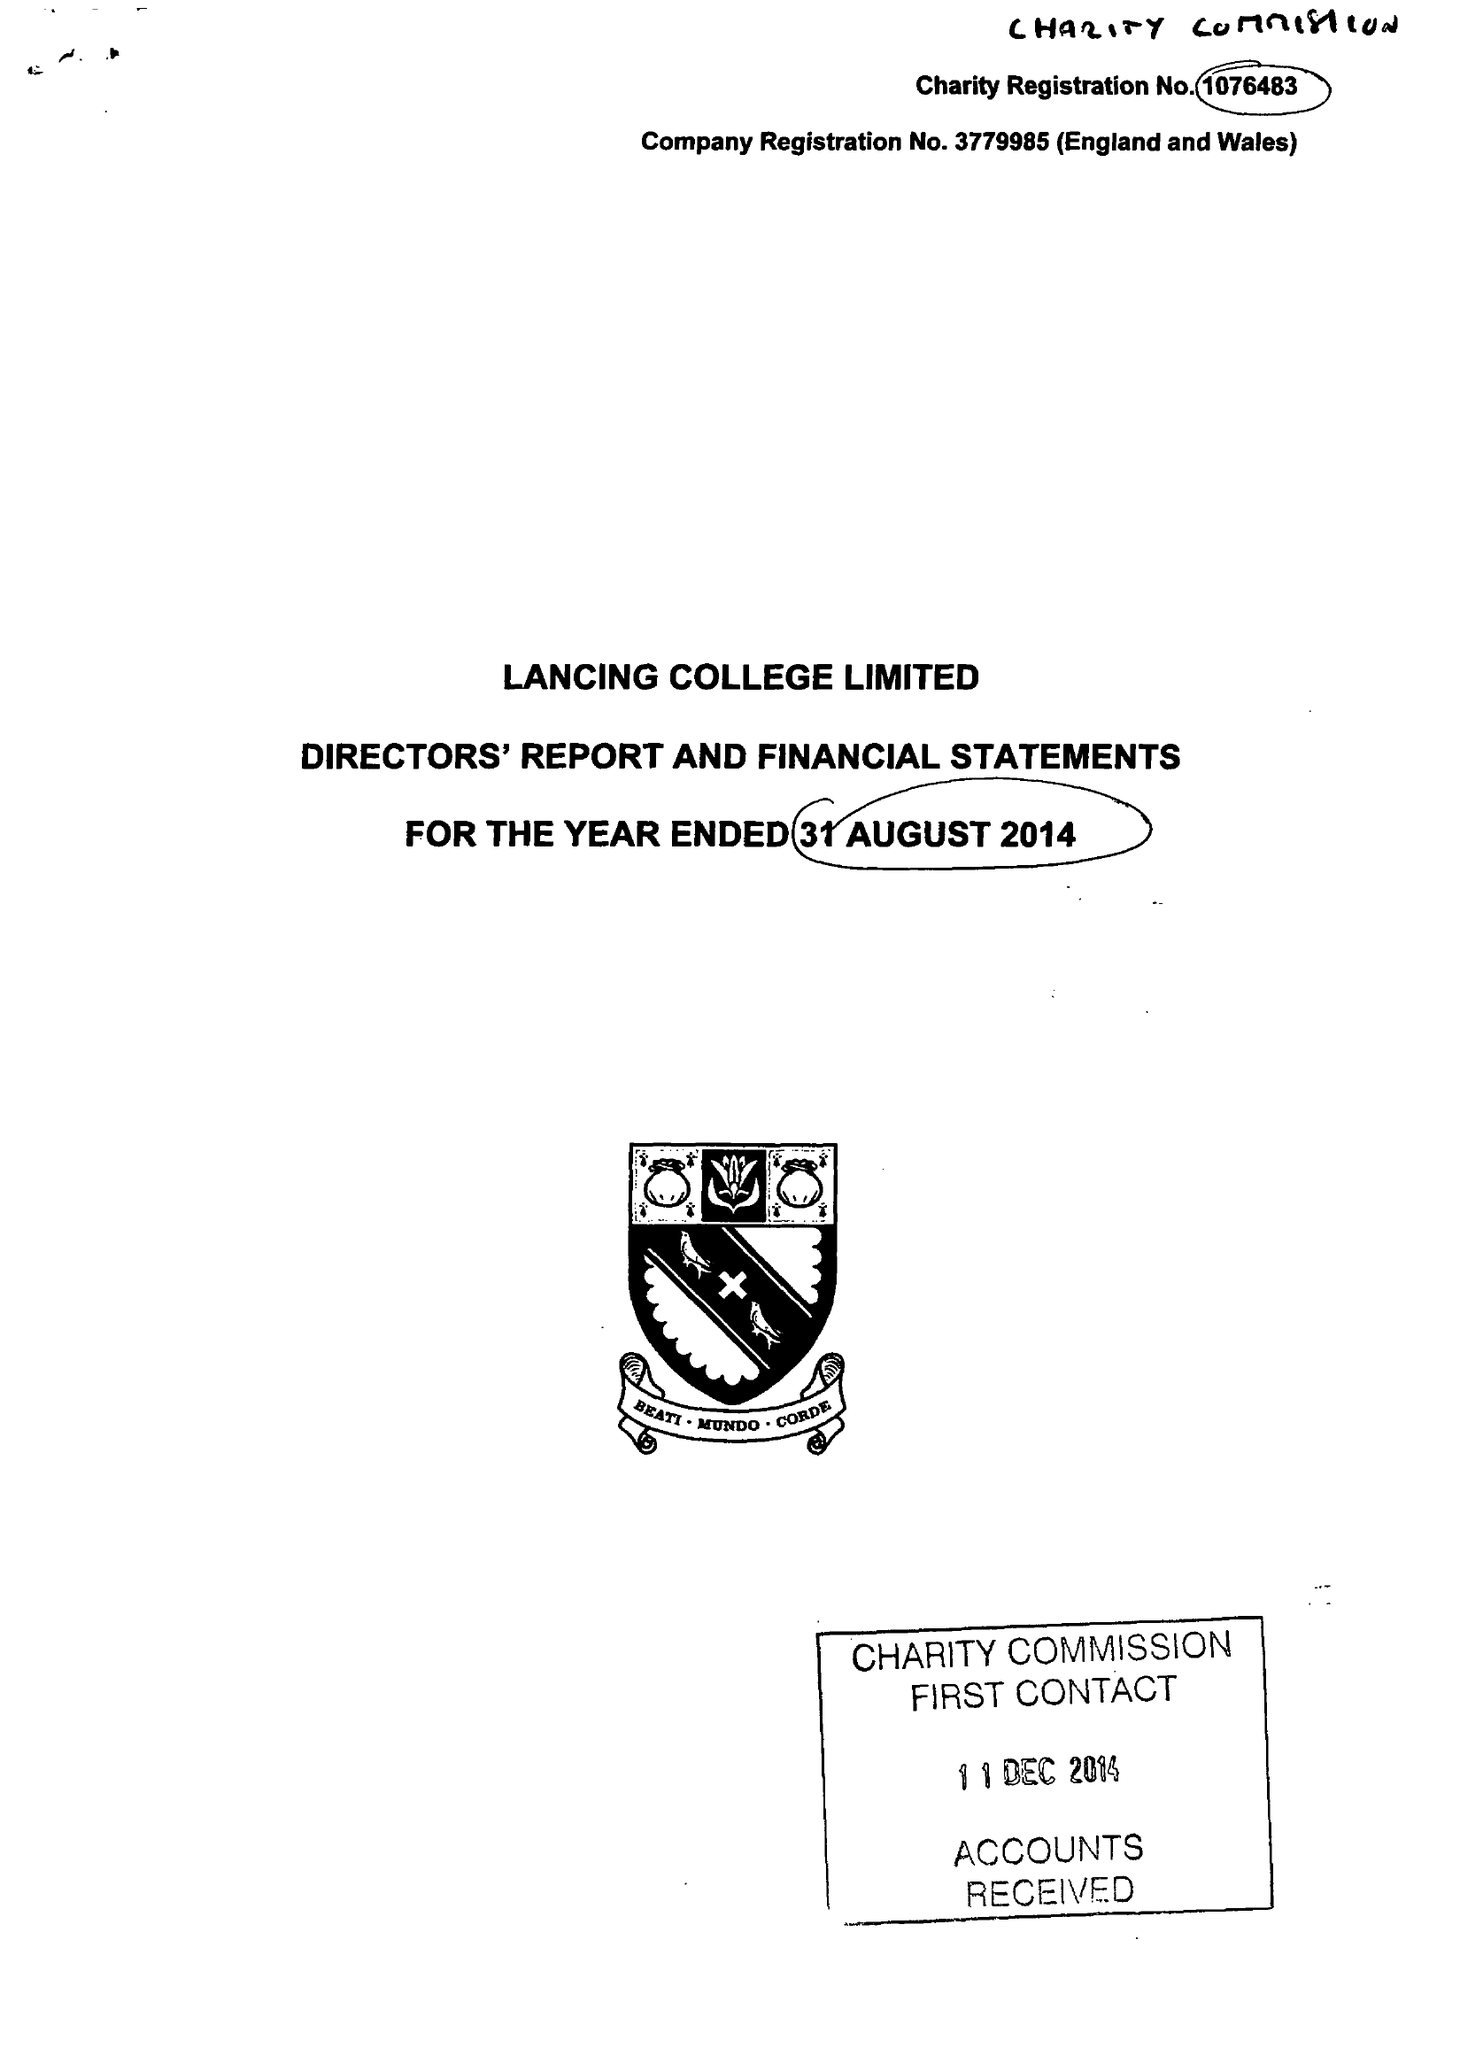What is the value for the income_annually_in_british_pounds?
Answer the question using a single word or phrase. 17367478.00 